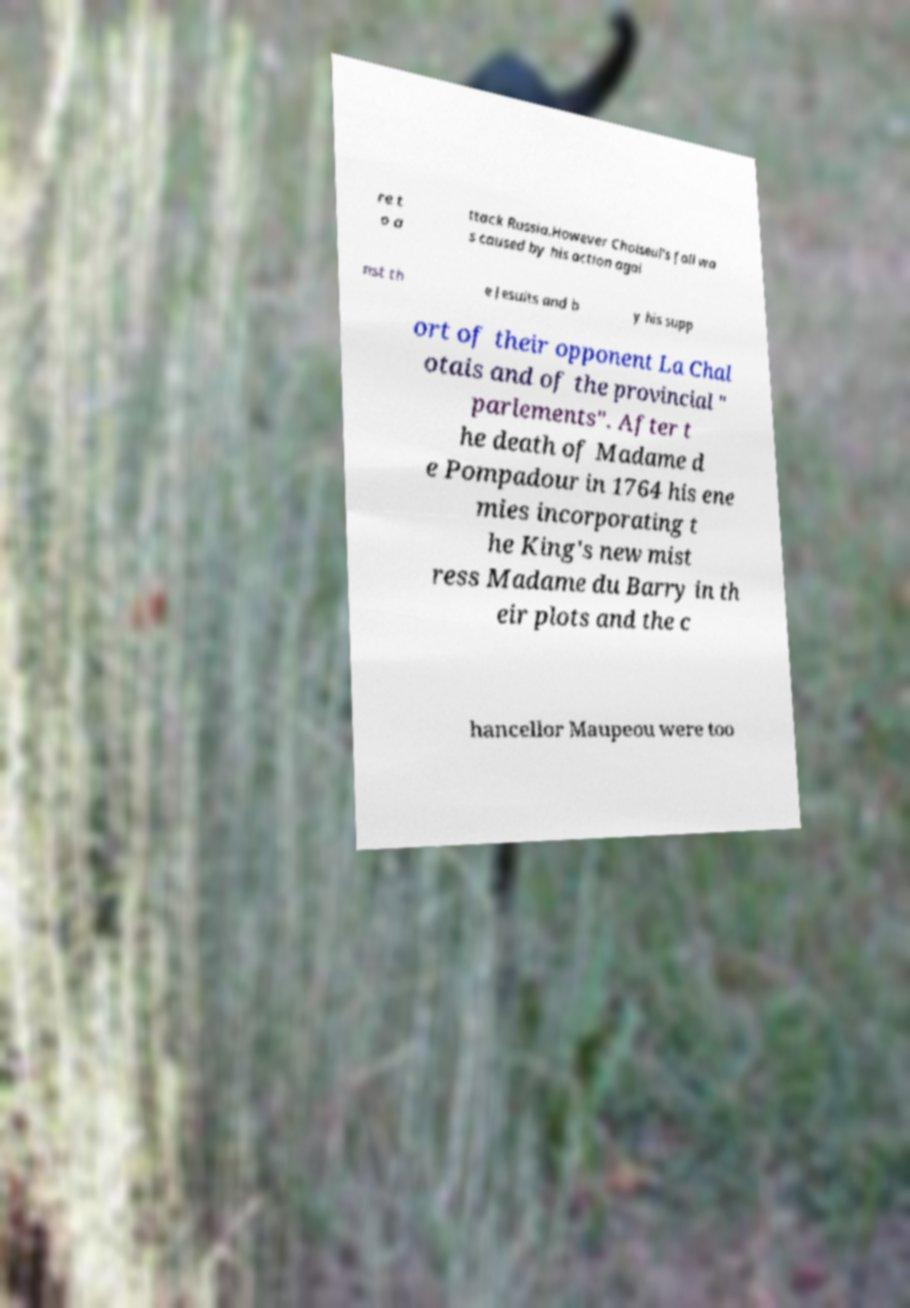For documentation purposes, I need the text within this image transcribed. Could you provide that? re t o a ttack Russia.However Choiseul's fall wa s caused by his action agai nst th e Jesuits and b y his supp ort of their opponent La Chal otais and of the provincial " parlements". After t he death of Madame d e Pompadour in 1764 his ene mies incorporating t he King's new mist ress Madame du Barry in th eir plots and the c hancellor Maupeou were too 